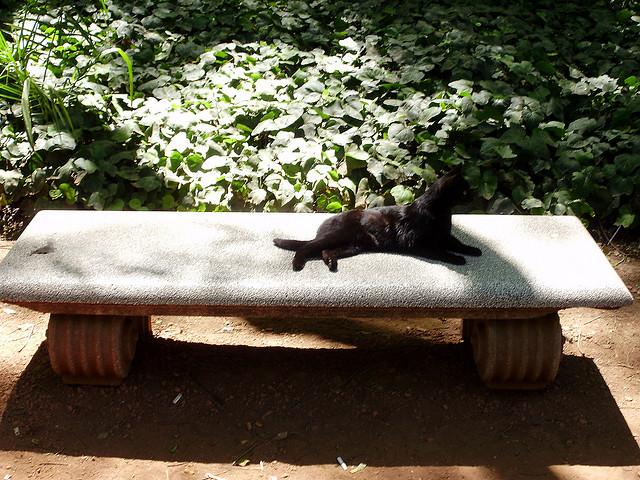Is the dog enjoying the sun?
Short answer required. Yes. Is this a dog or cat?
Short answer required. Cat. What is the animal sitting on?
Concise answer only. Bench. 